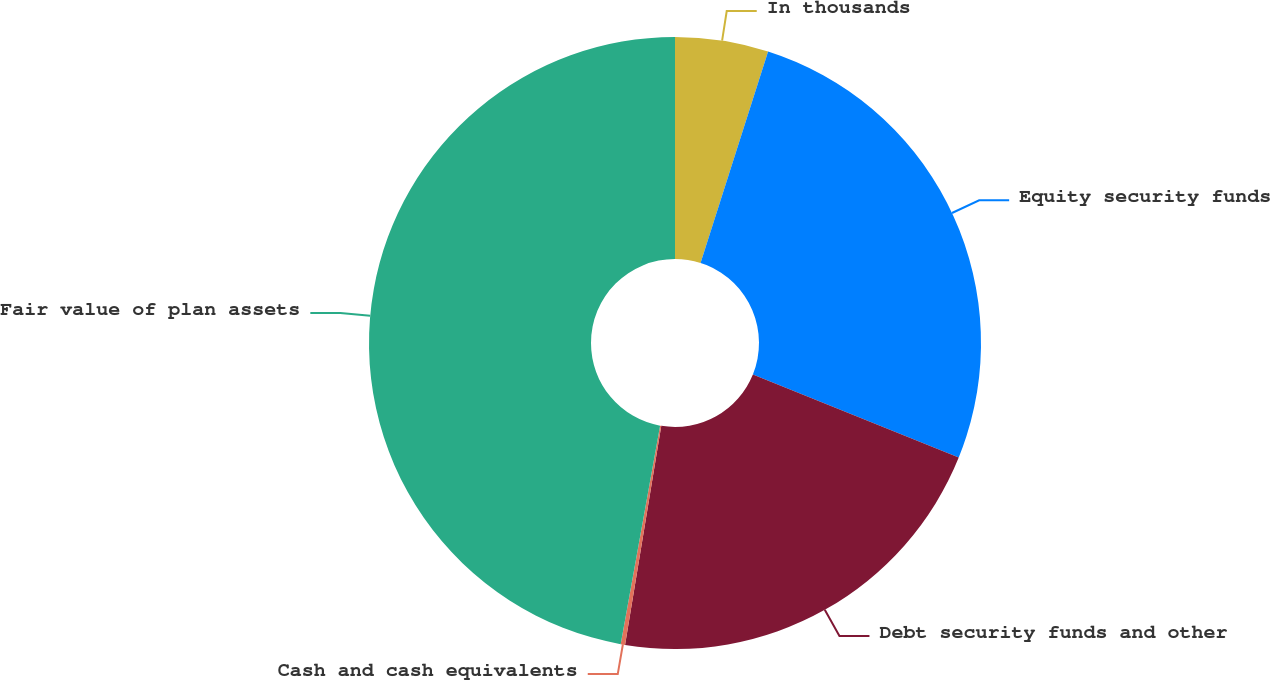Convert chart. <chart><loc_0><loc_0><loc_500><loc_500><pie_chart><fcel>In thousands<fcel>Equity security funds<fcel>Debt security funds and other<fcel>Cash and cash equivalents<fcel>Fair value of plan assets<nl><fcel>4.92%<fcel>26.19%<fcel>21.5%<fcel>0.23%<fcel>47.16%<nl></chart> 